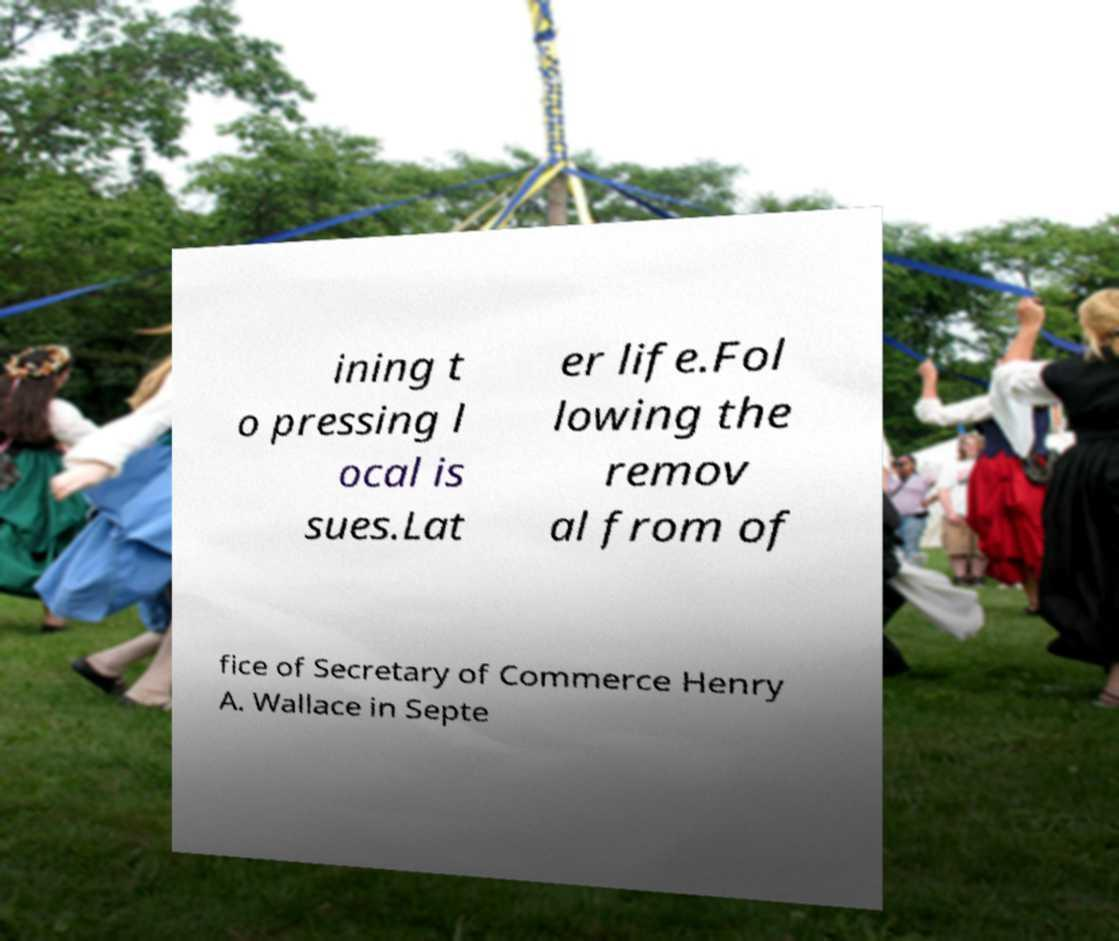Please read and relay the text visible in this image. What does it say? ining t o pressing l ocal is sues.Lat er life.Fol lowing the remov al from of fice of Secretary of Commerce Henry A. Wallace in Septe 